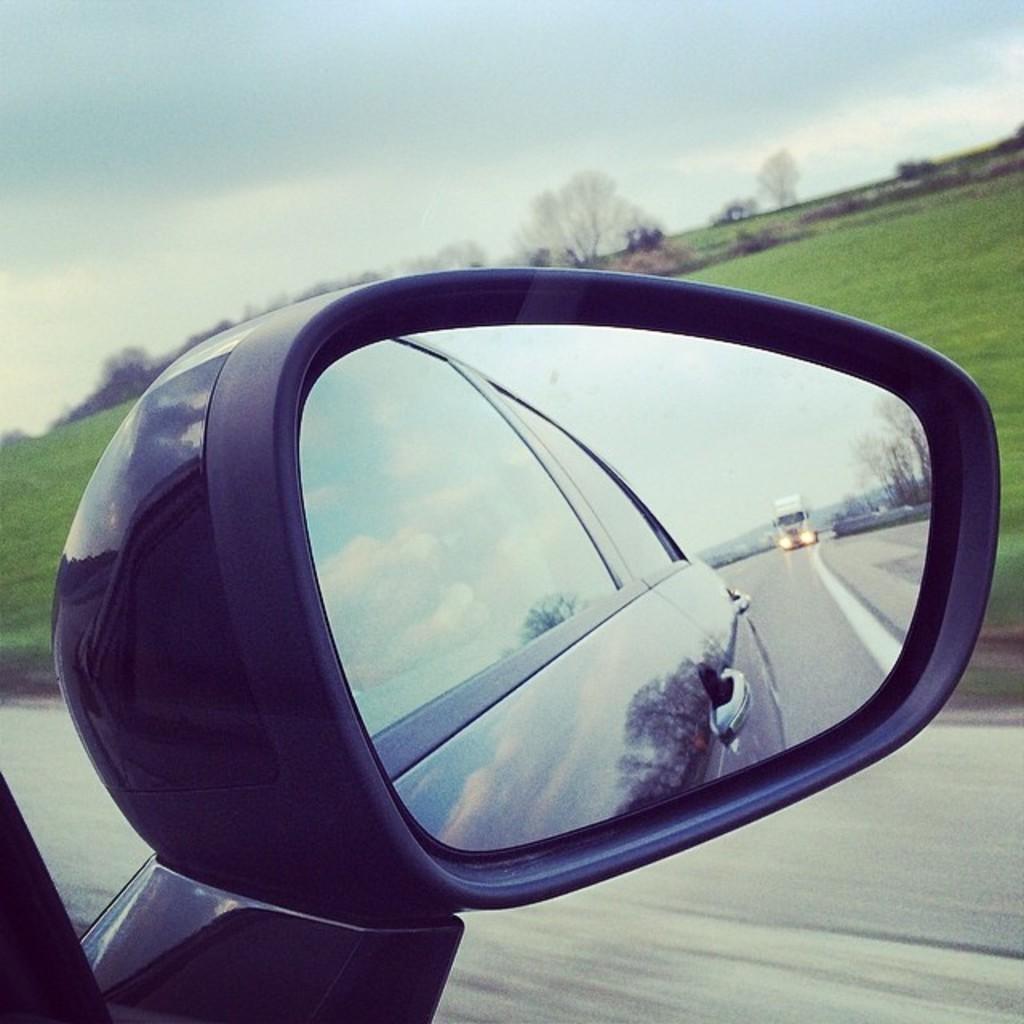Describe this image in one or two sentences. In the image there is a mirror. Inside the mirror there is a reflection of a car. And to the left side of the mirror there is a road with a truck. And behind the mirror on the ground there is a grass. And also there are trees and to the top of the image there is a sky. 